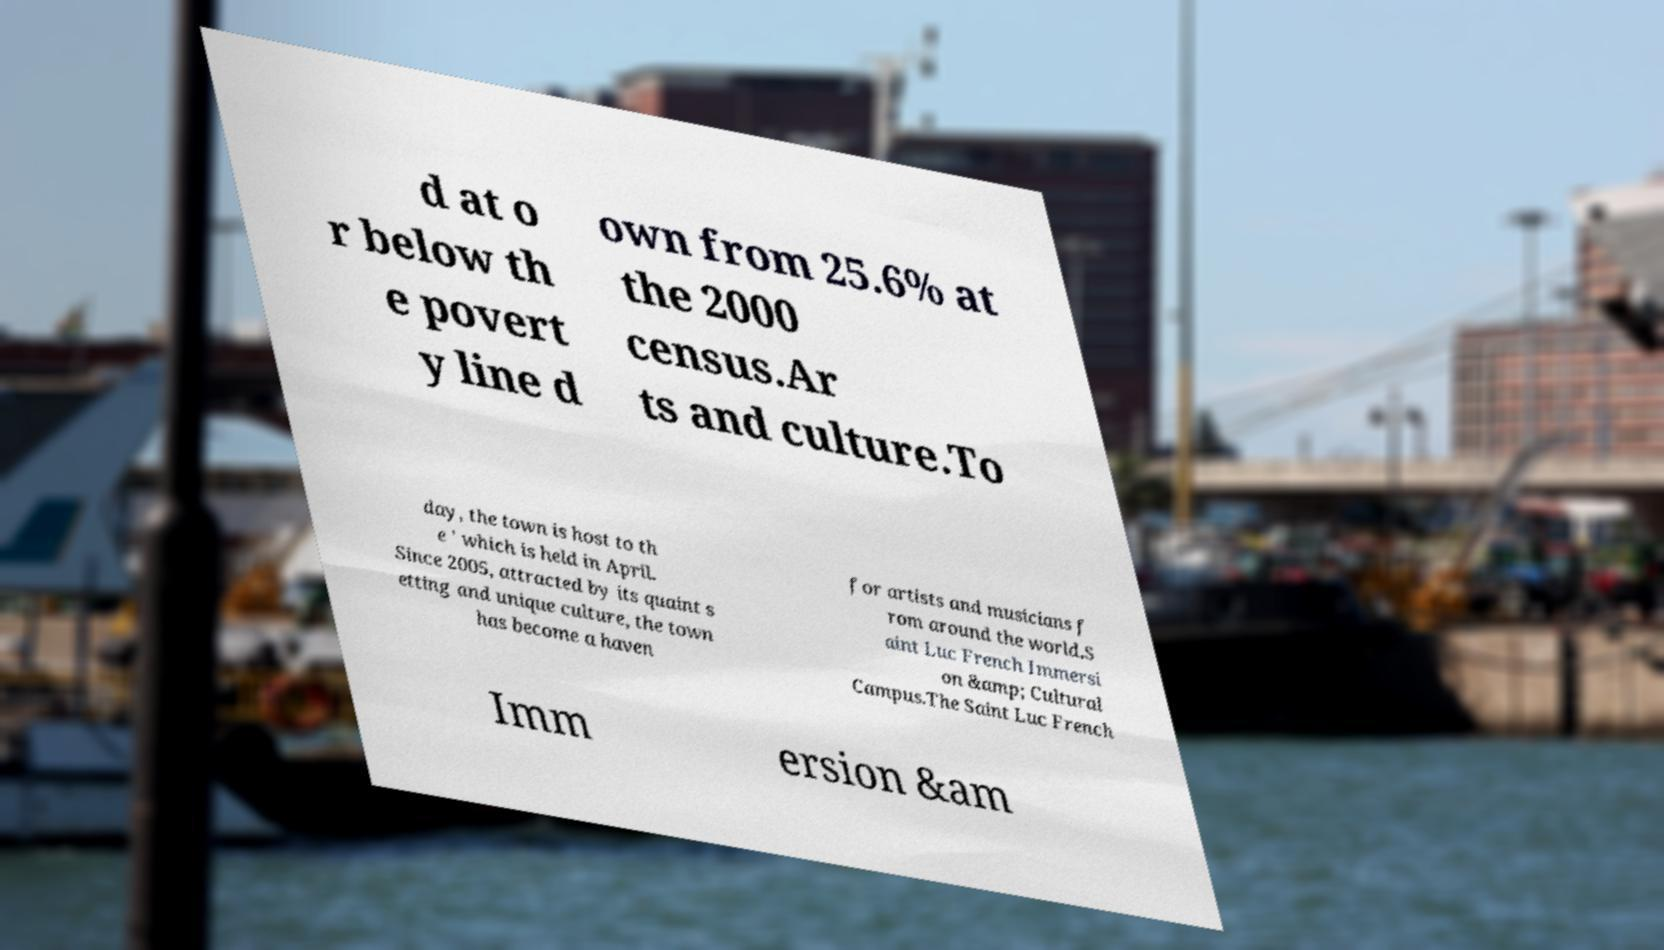Could you extract and type out the text from this image? d at o r below th e povert y line d own from 25.6% at the 2000 census.Ar ts and culture.To day, the town is host to th e ' which is held in April. Since 2005, attracted by its quaint s etting and unique culture, the town has become a haven for artists and musicians f rom around the world.S aint Luc French Immersi on &amp; Cultural Campus.The Saint Luc French Imm ersion &am 